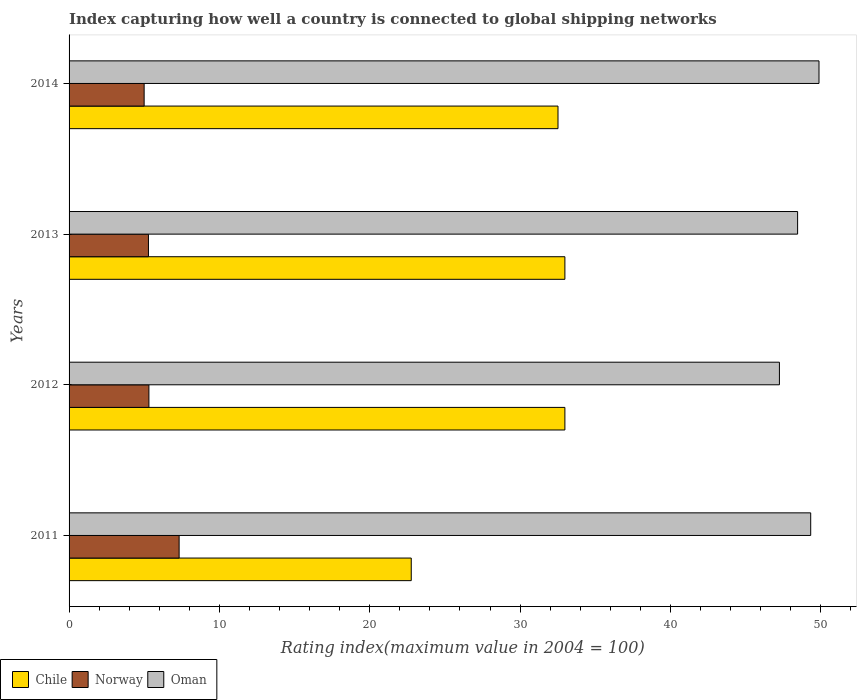Are the number of bars per tick equal to the number of legend labels?
Your answer should be compact. Yes. Are the number of bars on each tick of the Y-axis equal?
Offer a terse response. Yes. How many bars are there on the 3rd tick from the bottom?
Offer a terse response. 3. What is the label of the 3rd group of bars from the top?
Make the answer very short. 2012. In how many cases, is the number of bars for a given year not equal to the number of legend labels?
Ensure brevity in your answer.  0. What is the rating index in Chile in 2013?
Provide a short and direct response. 32.98. Across all years, what is the maximum rating index in Oman?
Ensure brevity in your answer.  49.88. Across all years, what is the minimum rating index in Oman?
Make the answer very short. 47.25. What is the total rating index in Chile in the graph?
Ensure brevity in your answer.  121.24. What is the difference between the rating index in Chile in 2012 and that in 2013?
Your answer should be very brief. 0. What is the difference between the rating index in Oman in 2011 and the rating index in Norway in 2012?
Offer a very short reply. 44.02. What is the average rating index in Oman per year?
Offer a very short reply. 48.73. In the year 2012, what is the difference between the rating index in Chile and rating index in Oman?
Offer a terse response. -14.27. What is the ratio of the rating index in Oman in 2013 to that in 2014?
Your answer should be very brief. 0.97. Is the difference between the rating index in Chile in 2012 and 2013 greater than the difference between the rating index in Oman in 2012 and 2013?
Offer a terse response. Yes. What is the difference between the highest and the second highest rating index in Norway?
Provide a short and direct response. 2.01. What is the difference between the highest and the lowest rating index in Norway?
Provide a short and direct response. 2.33. In how many years, is the rating index in Oman greater than the average rating index in Oman taken over all years?
Your answer should be compact. 2. What does the 1st bar from the top in 2014 represents?
Your answer should be compact. Oman. What does the 3rd bar from the bottom in 2014 represents?
Provide a succinct answer. Oman. How many bars are there?
Your answer should be compact. 12. Does the graph contain any zero values?
Make the answer very short. No. Does the graph contain grids?
Offer a terse response. No. Where does the legend appear in the graph?
Offer a terse response. Bottom left. How many legend labels are there?
Provide a short and direct response. 3. How are the legend labels stacked?
Make the answer very short. Horizontal. What is the title of the graph?
Your answer should be compact. Index capturing how well a country is connected to global shipping networks. Does "Kazakhstan" appear as one of the legend labels in the graph?
Provide a succinct answer. No. What is the label or title of the X-axis?
Offer a terse response. Rating index(maximum value in 2004 = 100). What is the Rating index(maximum value in 2004 = 100) in Chile in 2011?
Your answer should be compact. 22.76. What is the Rating index(maximum value in 2004 = 100) in Norway in 2011?
Give a very brief answer. 7.32. What is the Rating index(maximum value in 2004 = 100) in Oman in 2011?
Your answer should be compact. 49.33. What is the Rating index(maximum value in 2004 = 100) of Chile in 2012?
Offer a very short reply. 32.98. What is the Rating index(maximum value in 2004 = 100) in Norway in 2012?
Provide a succinct answer. 5.31. What is the Rating index(maximum value in 2004 = 100) in Oman in 2012?
Your response must be concise. 47.25. What is the Rating index(maximum value in 2004 = 100) of Chile in 2013?
Make the answer very short. 32.98. What is the Rating index(maximum value in 2004 = 100) in Norway in 2013?
Your answer should be compact. 5.28. What is the Rating index(maximum value in 2004 = 100) of Oman in 2013?
Provide a short and direct response. 48.46. What is the Rating index(maximum value in 2004 = 100) of Chile in 2014?
Give a very brief answer. 32.52. What is the Rating index(maximum value in 2004 = 100) of Norway in 2014?
Offer a very short reply. 4.99. What is the Rating index(maximum value in 2004 = 100) of Oman in 2014?
Ensure brevity in your answer.  49.88. Across all years, what is the maximum Rating index(maximum value in 2004 = 100) of Chile?
Ensure brevity in your answer.  32.98. Across all years, what is the maximum Rating index(maximum value in 2004 = 100) of Norway?
Ensure brevity in your answer.  7.32. Across all years, what is the maximum Rating index(maximum value in 2004 = 100) of Oman?
Ensure brevity in your answer.  49.88. Across all years, what is the minimum Rating index(maximum value in 2004 = 100) of Chile?
Your answer should be compact. 22.76. Across all years, what is the minimum Rating index(maximum value in 2004 = 100) of Norway?
Provide a short and direct response. 4.99. Across all years, what is the minimum Rating index(maximum value in 2004 = 100) in Oman?
Give a very brief answer. 47.25. What is the total Rating index(maximum value in 2004 = 100) of Chile in the graph?
Provide a short and direct response. 121.24. What is the total Rating index(maximum value in 2004 = 100) in Norway in the graph?
Provide a succinct answer. 22.9. What is the total Rating index(maximum value in 2004 = 100) in Oman in the graph?
Give a very brief answer. 194.92. What is the difference between the Rating index(maximum value in 2004 = 100) in Chile in 2011 and that in 2012?
Make the answer very short. -10.22. What is the difference between the Rating index(maximum value in 2004 = 100) in Norway in 2011 and that in 2012?
Keep it short and to the point. 2.01. What is the difference between the Rating index(maximum value in 2004 = 100) in Oman in 2011 and that in 2012?
Provide a succinct answer. 2.08. What is the difference between the Rating index(maximum value in 2004 = 100) of Chile in 2011 and that in 2013?
Your answer should be compact. -10.22. What is the difference between the Rating index(maximum value in 2004 = 100) in Norway in 2011 and that in 2013?
Make the answer very short. 2.04. What is the difference between the Rating index(maximum value in 2004 = 100) in Oman in 2011 and that in 2013?
Provide a succinct answer. 0.87. What is the difference between the Rating index(maximum value in 2004 = 100) of Chile in 2011 and that in 2014?
Make the answer very short. -9.76. What is the difference between the Rating index(maximum value in 2004 = 100) of Norway in 2011 and that in 2014?
Keep it short and to the point. 2.33. What is the difference between the Rating index(maximum value in 2004 = 100) of Oman in 2011 and that in 2014?
Your answer should be compact. -0.55. What is the difference between the Rating index(maximum value in 2004 = 100) in Chile in 2012 and that in 2013?
Ensure brevity in your answer.  0. What is the difference between the Rating index(maximum value in 2004 = 100) in Oman in 2012 and that in 2013?
Give a very brief answer. -1.21. What is the difference between the Rating index(maximum value in 2004 = 100) in Chile in 2012 and that in 2014?
Your answer should be compact. 0.46. What is the difference between the Rating index(maximum value in 2004 = 100) of Norway in 2012 and that in 2014?
Ensure brevity in your answer.  0.32. What is the difference between the Rating index(maximum value in 2004 = 100) in Oman in 2012 and that in 2014?
Provide a succinct answer. -2.63. What is the difference between the Rating index(maximum value in 2004 = 100) of Chile in 2013 and that in 2014?
Provide a succinct answer. 0.46. What is the difference between the Rating index(maximum value in 2004 = 100) of Norway in 2013 and that in 2014?
Offer a very short reply. 0.29. What is the difference between the Rating index(maximum value in 2004 = 100) in Oman in 2013 and that in 2014?
Offer a terse response. -1.42. What is the difference between the Rating index(maximum value in 2004 = 100) of Chile in 2011 and the Rating index(maximum value in 2004 = 100) of Norway in 2012?
Your answer should be compact. 17.45. What is the difference between the Rating index(maximum value in 2004 = 100) in Chile in 2011 and the Rating index(maximum value in 2004 = 100) in Oman in 2012?
Make the answer very short. -24.49. What is the difference between the Rating index(maximum value in 2004 = 100) in Norway in 2011 and the Rating index(maximum value in 2004 = 100) in Oman in 2012?
Keep it short and to the point. -39.93. What is the difference between the Rating index(maximum value in 2004 = 100) of Chile in 2011 and the Rating index(maximum value in 2004 = 100) of Norway in 2013?
Provide a succinct answer. 17.48. What is the difference between the Rating index(maximum value in 2004 = 100) of Chile in 2011 and the Rating index(maximum value in 2004 = 100) of Oman in 2013?
Your answer should be very brief. -25.7. What is the difference between the Rating index(maximum value in 2004 = 100) in Norway in 2011 and the Rating index(maximum value in 2004 = 100) in Oman in 2013?
Provide a succinct answer. -41.14. What is the difference between the Rating index(maximum value in 2004 = 100) in Chile in 2011 and the Rating index(maximum value in 2004 = 100) in Norway in 2014?
Give a very brief answer. 17.77. What is the difference between the Rating index(maximum value in 2004 = 100) of Chile in 2011 and the Rating index(maximum value in 2004 = 100) of Oman in 2014?
Your answer should be compact. -27.12. What is the difference between the Rating index(maximum value in 2004 = 100) in Norway in 2011 and the Rating index(maximum value in 2004 = 100) in Oman in 2014?
Provide a short and direct response. -42.56. What is the difference between the Rating index(maximum value in 2004 = 100) of Chile in 2012 and the Rating index(maximum value in 2004 = 100) of Norway in 2013?
Offer a very short reply. 27.7. What is the difference between the Rating index(maximum value in 2004 = 100) in Chile in 2012 and the Rating index(maximum value in 2004 = 100) in Oman in 2013?
Your response must be concise. -15.48. What is the difference between the Rating index(maximum value in 2004 = 100) in Norway in 2012 and the Rating index(maximum value in 2004 = 100) in Oman in 2013?
Give a very brief answer. -43.15. What is the difference between the Rating index(maximum value in 2004 = 100) of Chile in 2012 and the Rating index(maximum value in 2004 = 100) of Norway in 2014?
Offer a very short reply. 27.99. What is the difference between the Rating index(maximum value in 2004 = 100) in Chile in 2012 and the Rating index(maximum value in 2004 = 100) in Oman in 2014?
Make the answer very short. -16.9. What is the difference between the Rating index(maximum value in 2004 = 100) of Norway in 2012 and the Rating index(maximum value in 2004 = 100) of Oman in 2014?
Your response must be concise. -44.57. What is the difference between the Rating index(maximum value in 2004 = 100) in Chile in 2013 and the Rating index(maximum value in 2004 = 100) in Norway in 2014?
Your answer should be compact. 27.99. What is the difference between the Rating index(maximum value in 2004 = 100) of Chile in 2013 and the Rating index(maximum value in 2004 = 100) of Oman in 2014?
Ensure brevity in your answer.  -16.9. What is the difference between the Rating index(maximum value in 2004 = 100) of Norway in 2013 and the Rating index(maximum value in 2004 = 100) of Oman in 2014?
Offer a terse response. -44.6. What is the average Rating index(maximum value in 2004 = 100) in Chile per year?
Provide a short and direct response. 30.31. What is the average Rating index(maximum value in 2004 = 100) in Norway per year?
Your response must be concise. 5.73. What is the average Rating index(maximum value in 2004 = 100) of Oman per year?
Your answer should be very brief. 48.73. In the year 2011, what is the difference between the Rating index(maximum value in 2004 = 100) in Chile and Rating index(maximum value in 2004 = 100) in Norway?
Your answer should be very brief. 15.44. In the year 2011, what is the difference between the Rating index(maximum value in 2004 = 100) of Chile and Rating index(maximum value in 2004 = 100) of Oman?
Provide a succinct answer. -26.57. In the year 2011, what is the difference between the Rating index(maximum value in 2004 = 100) of Norway and Rating index(maximum value in 2004 = 100) of Oman?
Provide a short and direct response. -42.01. In the year 2012, what is the difference between the Rating index(maximum value in 2004 = 100) of Chile and Rating index(maximum value in 2004 = 100) of Norway?
Your answer should be very brief. 27.67. In the year 2012, what is the difference between the Rating index(maximum value in 2004 = 100) of Chile and Rating index(maximum value in 2004 = 100) of Oman?
Your answer should be very brief. -14.27. In the year 2012, what is the difference between the Rating index(maximum value in 2004 = 100) in Norway and Rating index(maximum value in 2004 = 100) in Oman?
Make the answer very short. -41.94. In the year 2013, what is the difference between the Rating index(maximum value in 2004 = 100) in Chile and Rating index(maximum value in 2004 = 100) in Norway?
Provide a short and direct response. 27.7. In the year 2013, what is the difference between the Rating index(maximum value in 2004 = 100) in Chile and Rating index(maximum value in 2004 = 100) in Oman?
Provide a succinct answer. -15.48. In the year 2013, what is the difference between the Rating index(maximum value in 2004 = 100) in Norway and Rating index(maximum value in 2004 = 100) in Oman?
Make the answer very short. -43.18. In the year 2014, what is the difference between the Rating index(maximum value in 2004 = 100) of Chile and Rating index(maximum value in 2004 = 100) of Norway?
Ensure brevity in your answer.  27.53. In the year 2014, what is the difference between the Rating index(maximum value in 2004 = 100) in Chile and Rating index(maximum value in 2004 = 100) in Oman?
Your answer should be very brief. -17.36. In the year 2014, what is the difference between the Rating index(maximum value in 2004 = 100) of Norway and Rating index(maximum value in 2004 = 100) of Oman?
Your answer should be very brief. -44.89. What is the ratio of the Rating index(maximum value in 2004 = 100) in Chile in 2011 to that in 2012?
Provide a succinct answer. 0.69. What is the ratio of the Rating index(maximum value in 2004 = 100) of Norway in 2011 to that in 2012?
Make the answer very short. 1.38. What is the ratio of the Rating index(maximum value in 2004 = 100) in Oman in 2011 to that in 2012?
Provide a short and direct response. 1.04. What is the ratio of the Rating index(maximum value in 2004 = 100) in Chile in 2011 to that in 2013?
Make the answer very short. 0.69. What is the ratio of the Rating index(maximum value in 2004 = 100) of Norway in 2011 to that in 2013?
Keep it short and to the point. 1.39. What is the ratio of the Rating index(maximum value in 2004 = 100) of Oman in 2011 to that in 2013?
Make the answer very short. 1.02. What is the ratio of the Rating index(maximum value in 2004 = 100) in Chile in 2011 to that in 2014?
Provide a short and direct response. 0.7. What is the ratio of the Rating index(maximum value in 2004 = 100) in Norway in 2011 to that in 2014?
Make the answer very short. 1.47. What is the ratio of the Rating index(maximum value in 2004 = 100) of Oman in 2011 to that in 2014?
Offer a very short reply. 0.99. What is the ratio of the Rating index(maximum value in 2004 = 100) in Norway in 2012 to that in 2013?
Provide a short and direct response. 1.01. What is the ratio of the Rating index(maximum value in 2004 = 100) in Chile in 2012 to that in 2014?
Your answer should be very brief. 1.01. What is the ratio of the Rating index(maximum value in 2004 = 100) in Norway in 2012 to that in 2014?
Ensure brevity in your answer.  1.06. What is the ratio of the Rating index(maximum value in 2004 = 100) in Oman in 2012 to that in 2014?
Keep it short and to the point. 0.95. What is the ratio of the Rating index(maximum value in 2004 = 100) of Chile in 2013 to that in 2014?
Keep it short and to the point. 1.01. What is the ratio of the Rating index(maximum value in 2004 = 100) of Norway in 2013 to that in 2014?
Provide a short and direct response. 1.06. What is the ratio of the Rating index(maximum value in 2004 = 100) in Oman in 2013 to that in 2014?
Provide a succinct answer. 0.97. What is the difference between the highest and the second highest Rating index(maximum value in 2004 = 100) in Norway?
Provide a short and direct response. 2.01. What is the difference between the highest and the second highest Rating index(maximum value in 2004 = 100) in Oman?
Your answer should be compact. 0.55. What is the difference between the highest and the lowest Rating index(maximum value in 2004 = 100) of Chile?
Give a very brief answer. 10.22. What is the difference between the highest and the lowest Rating index(maximum value in 2004 = 100) in Norway?
Offer a very short reply. 2.33. What is the difference between the highest and the lowest Rating index(maximum value in 2004 = 100) in Oman?
Your answer should be compact. 2.63. 